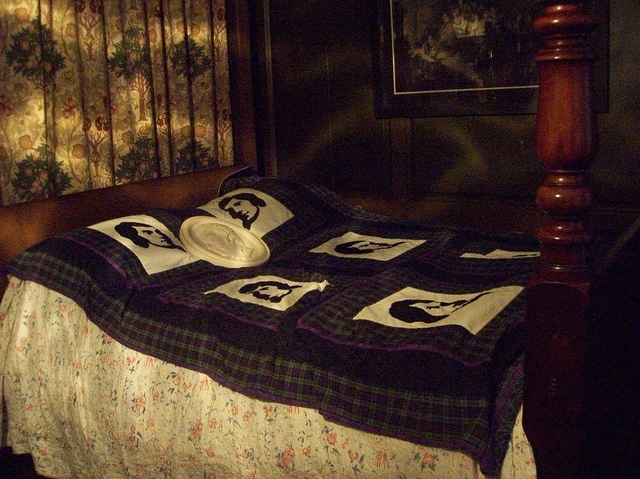Describe the objects in this image and their specific colors. I can see bed in olive, black, tan, and maroon tones, people in olive, black, tan, and gray tones, people in olive, black, tan, maroon, and gray tones, and people in olive, black, and gray tones in this image. 